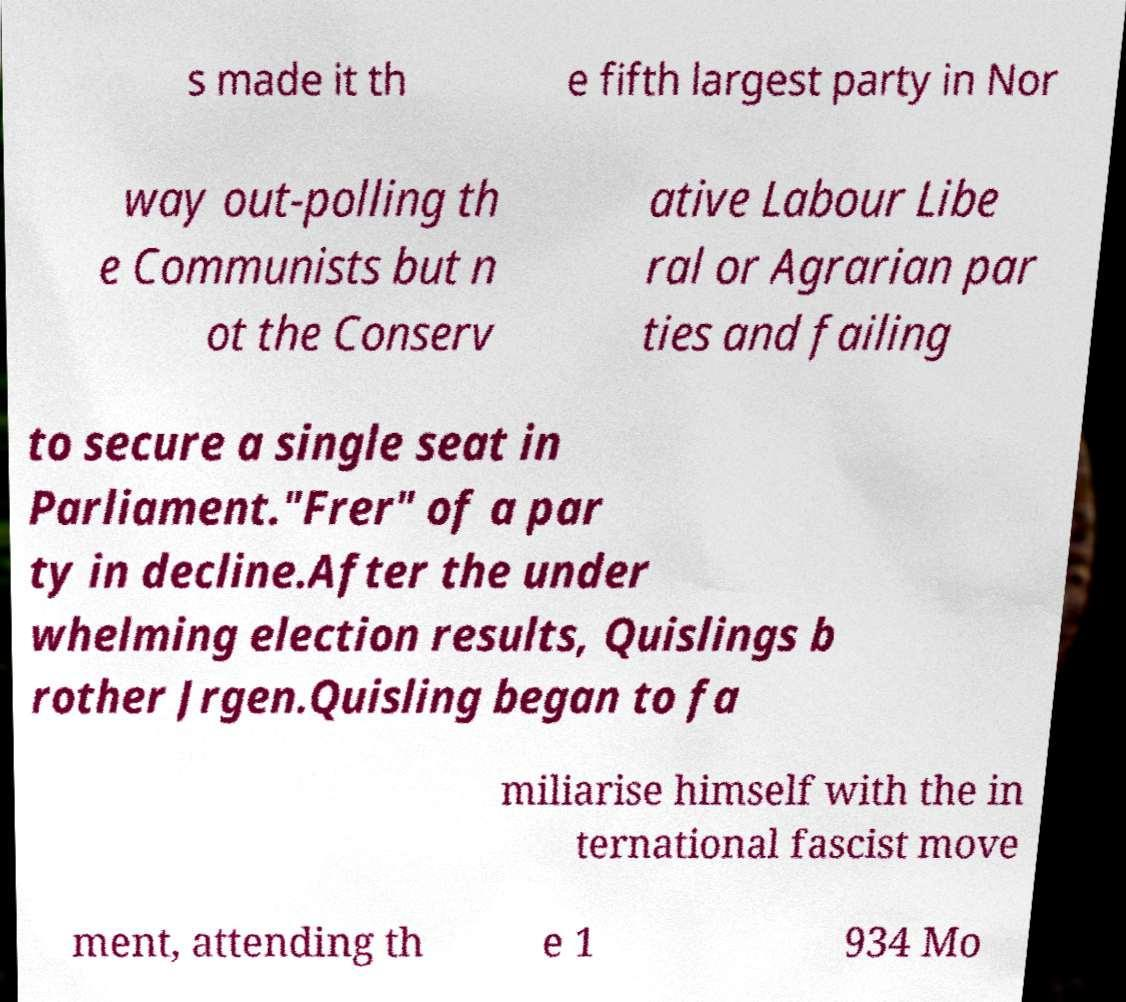Please read and relay the text visible in this image. What does it say? s made it th e fifth largest party in Nor way out-polling th e Communists but n ot the Conserv ative Labour Libe ral or Agrarian par ties and failing to secure a single seat in Parliament."Frer" of a par ty in decline.After the under whelming election results, Quislings b rother Jrgen.Quisling began to fa miliarise himself with the in ternational fascist move ment, attending th e 1 934 Mo 